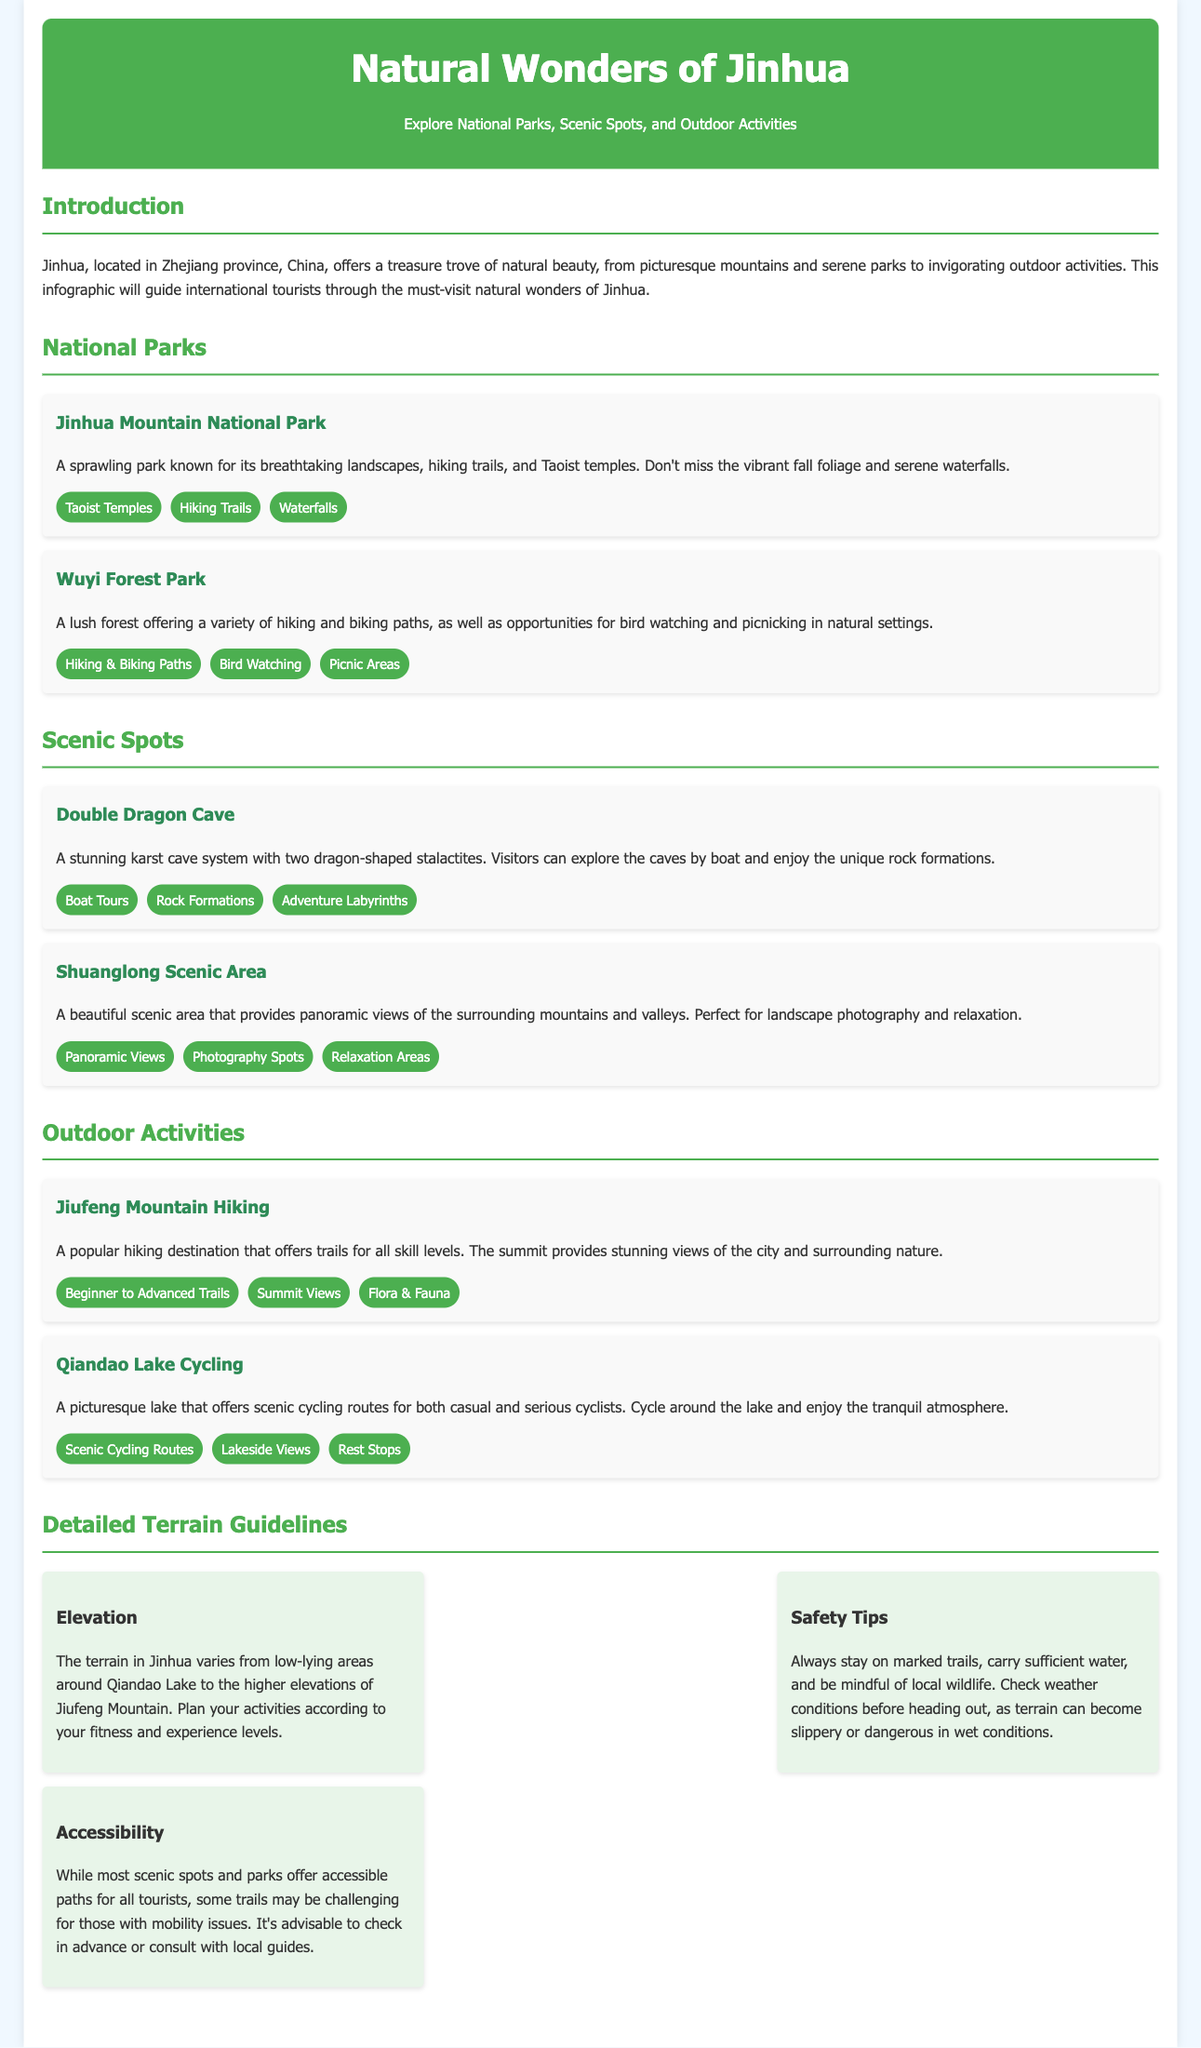What are the two national parks mentioned? The document lists two national parks, which are Jinhua Mountain National Park and Wuyi Forest Park.
Answer: Jinhua Mountain National Park, Wuyi Forest Park What outdoor activity is popular at Jiufeng Mountain? The document mentions hiking as a popular outdoor activity at Jiufeng Mountain, with trails for all skill levels.
Answer: Hiking What scenic spot offers boat tours? The Double Dragon Cave is noted for offering boat tours to explore its stunning karst cave system.
Answer: Double Dragon Cave What type of cycling routes does Qiandao Lake offer? Qiandao Lake provides scenic cycling routes suitable for both casual and serious cyclists as per the document.
Answer: Scenic cycling routes What is a recommended safety tip for outdoor activities? The document advises tourists to always stay on marked trails as one of the safety tips.
Answer: Stay on marked trails What is the elevation variation in Jinhua? The terrain in Jinhua varies from low-lying areas around Qiandao Lake to higher elevations at Jiufeng Mountain.
Answer: Low-lying to higher elevations What type of photography is recommended in Shuanglong Scenic Area? The scenic area is noted for its panoramic views, making it perfect for landscape photography.
Answer: Landscape photography How are the terrain guidelines categorized? The guidelines are categorized into three aspects: Elevation, Safety Tips, and Accessibility.
Answer: Elevation, Safety Tips, Accessibility 